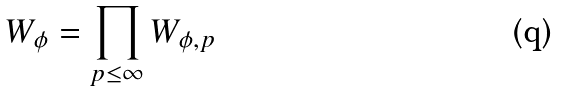<formula> <loc_0><loc_0><loc_500><loc_500>W _ { \phi } = \prod _ { p \leq \infty } W _ { \phi , p }</formula> 